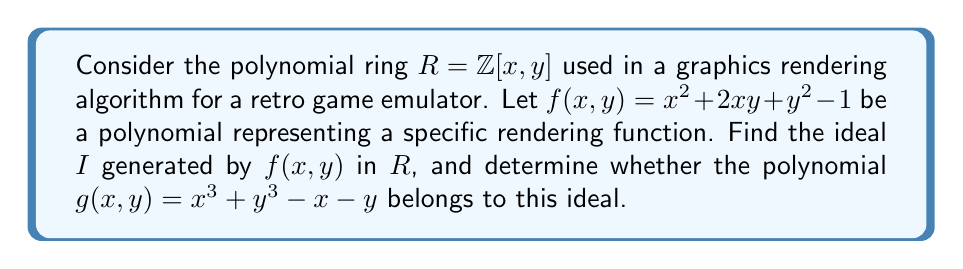Can you answer this question? To solve this problem, we need to follow these steps:

1. Understand the ideal generated by $f(x, y)$:
   The ideal $I$ generated by $f(x, y)$ in $R$ is defined as:
   $$I = \langle f(x, y) \rangle = \{h(x, y) \cdot f(x, y) : h(x, y) \in R\}$$

2. To determine if $g(x, y)$ belongs to $I$, we need to check if there exists a polynomial $h(x, y) \in R$ such that:
   $$g(x, y) = h(x, y) \cdot f(x, y)$$

3. Let's attempt to divide $g(x, y)$ by $f(x, y)$:
   $$\frac{g(x, y)}{f(x, y)} = \frac{x^3 + y^3 - x - y}{x^2 + 2xy + y^2 - 1}$$

4. This division doesn't result in a polynomial quotient, which means $g(x, y)$ cannot be expressed as $h(x, y) \cdot f(x, y)$ for any $h(x, y) \in R$.

5. Therefore, $g(x, y)$ does not belong to the ideal $I$ generated by $f(x, y)$.

In the context of graphics rendering for retro game emulation, this result suggests that the rendering function represented by $g(x, y)$ cannot be directly derived from the function $f(x, y)$ using the operations allowed in the polynomial ring. This implies that $g(x, y)$ might represent a distinct rendering feature or effect that cannot be achieved by manipulating $f(x, y)$ alone.
Answer: The ideal $I$ generated by $f(x, y) = x^2 + 2xy + y^2 - 1$ in $R = \mathbb{Z}[x, y]$ is:
$$I = \langle x^2 + 2xy + y^2 - 1 \rangle = \{h(x, y) \cdot (x^2 + 2xy + y^2 - 1) : h(x, y) \in \mathbb{Z}[x, y]\}$$

The polynomial $g(x, y) = x^3 + y^3 - x - y$ does not belong to this ideal $I$. 